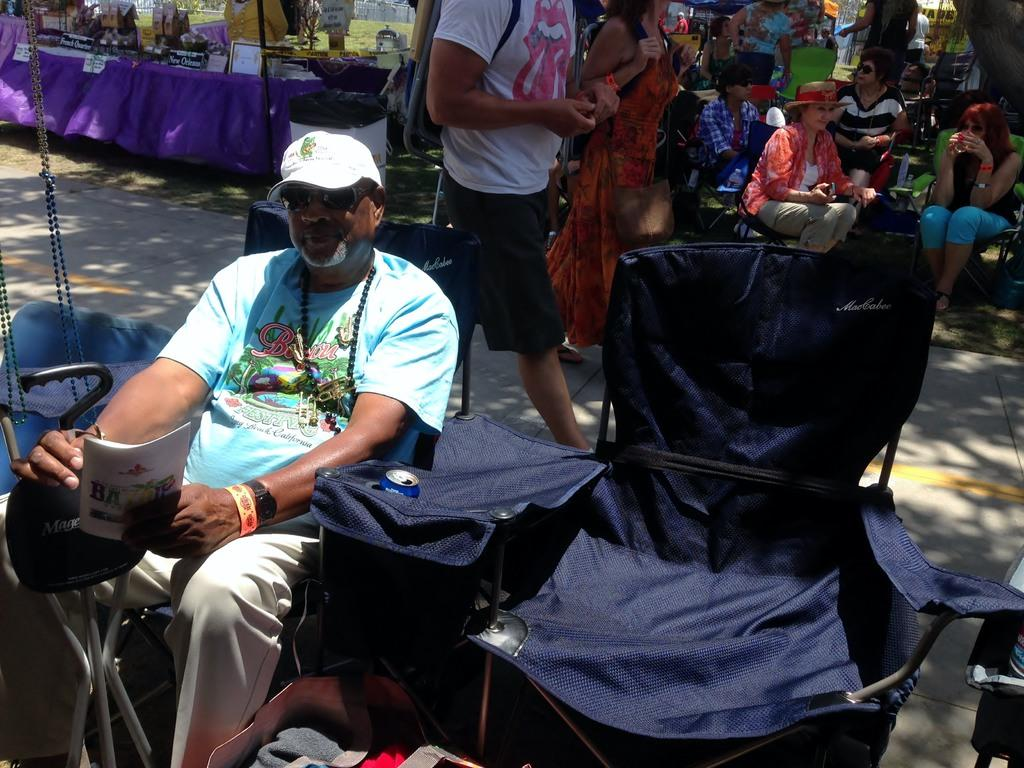What are the people in the image doing? There are groups of people sitting in the image. What can be seen in the background of the image? There is grass visible in the background of the image. What objects are on the left side of the image? There are photo frames, chairs, and a book on the left side of the image. Can you see a glove on the right side of the image? There is no glove present on the right side of the image. Are there any cacti visible in the image? There are no cacti present in the image; only grass is visible in the background. 